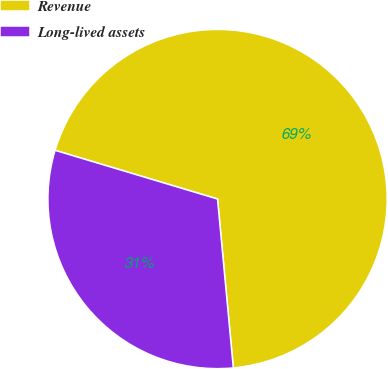Convert chart to OTSL. <chart><loc_0><loc_0><loc_500><loc_500><pie_chart><fcel>Revenue<fcel>Long-lived assets<nl><fcel>68.88%<fcel>31.12%<nl></chart> 